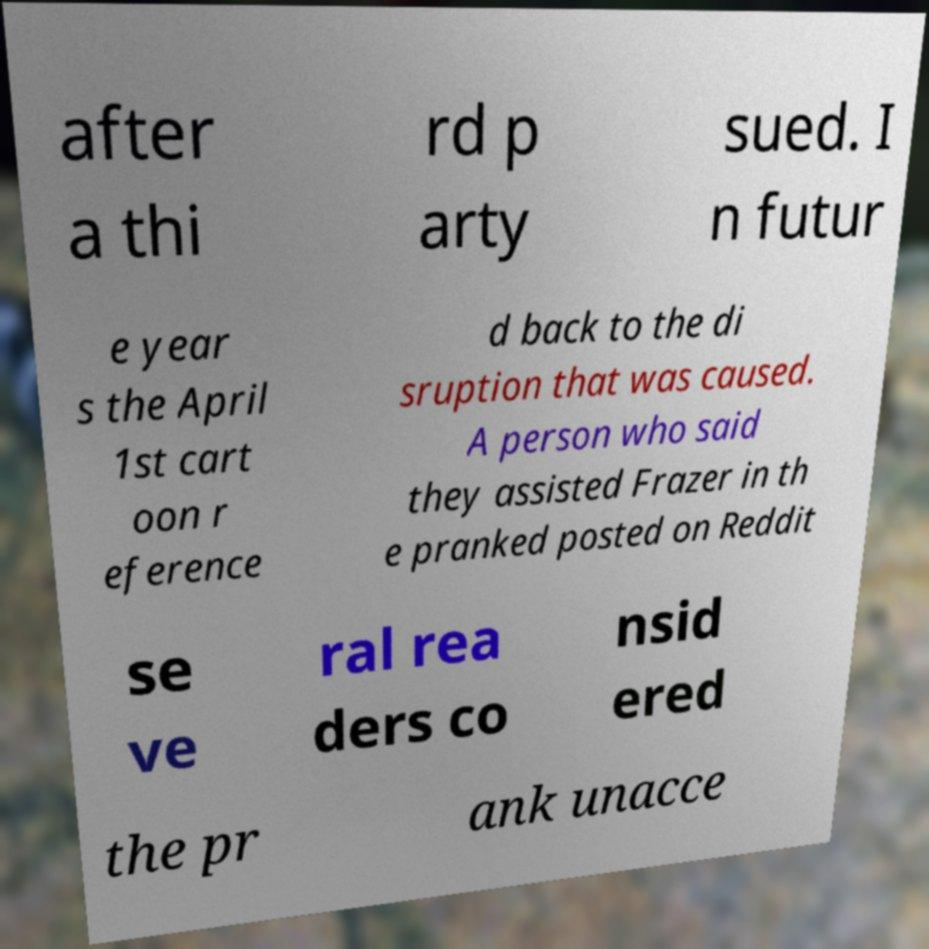For documentation purposes, I need the text within this image transcribed. Could you provide that? after a thi rd p arty sued. I n futur e year s the April 1st cart oon r eference d back to the di sruption that was caused. A person who said they assisted Frazer in th e pranked posted on Reddit se ve ral rea ders co nsid ered the pr ank unacce 